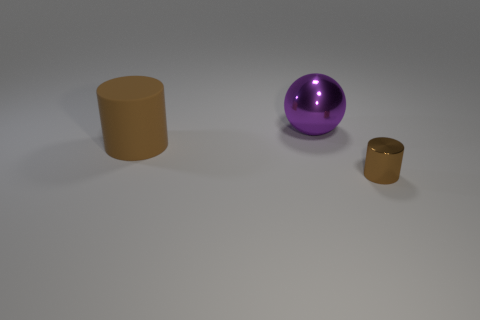There is a object that is the same color as the metallic cylinder; what size is it?
Keep it short and to the point. Large. Does the small metal object have the same shape as the large thing on the right side of the large brown matte cylinder?
Provide a short and direct response. No. There is a big thing that is on the left side of the large thing that is behind the cylinder that is behind the small brown metallic object; what is it made of?
Offer a terse response. Rubber. What number of shiny balls are there?
Your response must be concise. 1. How many cyan objects are either shiny balls or small shiny cylinders?
Make the answer very short. 0. How many other things are there of the same shape as the large matte thing?
Your answer should be very brief. 1. There is a large matte thing left of the purple metal thing; is its color the same as the metallic object that is left of the small metal thing?
Give a very brief answer. No. What number of large objects are either purple cylinders or purple balls?
Provide a succinct answer. 1. There is a rubber object that is the same shape as the brown metallic object; what size is it?
Your answer should be compact. Large. Is there anything else that has the same size as the rubber thing?
Your answer should be compact. Yes. 